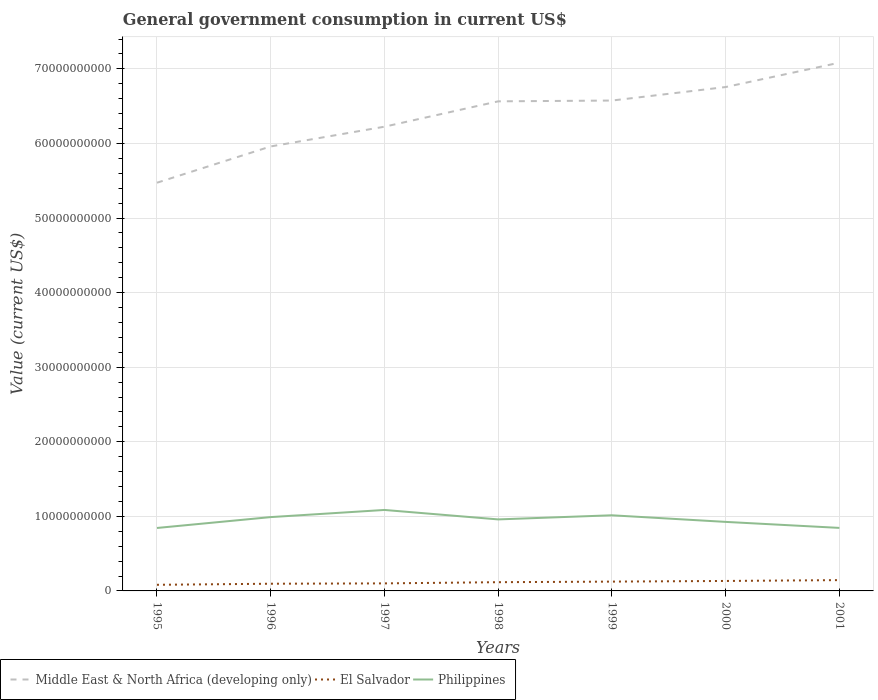Across all years, what is the maximum government conusmption in Middle East & North Africa (developing only)?
Provide a succinct answer. 5.47e+1. What is the total government conusmption in Philippines in the graph?
Provide a succinct answer. 2.41e+09. What is the difference between the highest and the second highest government conusmption in Middle East & North Africa (developing only)?
Ensure brevity in your answer.  1.61e+1. What is the difference between the highest and the lowest government conusmption in Middle East & North Africa (developing only)?
Keep it short and to the point. 4. Is the government conusmption in El Salvador strictly greater than the government conusmption in Philippines over the years?
Provide a short and direct response. Yes. How many lines are there?
Ensure brevity in your answer.  3. How many years are there in the graph?
Offer a very short reply. 7. Are the values on the major ticks of Y-axis written in scientific E-notation?
Offer a very short reply. No. Does the graph contain any zero values?
Provide a short and direct response. No. Does the graph contain grids?
Your answer should be very brief. Yes. Where does the legend appear in the graph?
Provide a short and direct response. Bottom left. How are the legend labels stacked?
Offer a very short reply. Horizontal. What is the title of the graph?
Your answer should be compact. General government consumption in current US$. What is the label or title of the Y-axis?
Keep it short and to the point. Value (current US$). What is the Value (current US$) of Middle East & North Africa (developing only) in 1995?
Ensure brevity in your answer.  5.47e+1. What is the Value (current US$) in El Salvador in 1995?
Your response must be concise. 8.21e+08. What is the Value (current US$) of Philippines in 1995?
Provide a short and direct response. 8.44e+09. What is the Value (current US$) in Middle East & North Africa (developing only) in 1996?
Offer a very short reply. 5.96e+1. What is the Value (current US$) of El Salvador in 1996?
Your answer should be very brief. 9.64e+08. What is the Value (current US$) in Philippines in 1996?
Offer a very short reply. 9.90e+09. What is the Value (current US$) in Middle East & North Africa (developing only) in 1997?
Provide a short and direct response. 6.22e+1. What is the Value (current US$) of El Salvador in 1997?
Provide a short and direct response. 1.01e+09. What is the Value (current US$) of Philippines in 1997?
Keep it short and to the point. 1.09e+1. What is the Value (current US$) of Middle East & North Africa (developing only) in 1998?
Ensure brevity in your answer.  6.56e+1. What is the Value (current US$) in El Salvador in 1998?
Make the answer very short. 1.17e+09. What is the Value (current US$) in Philippines in 1998?
Your response must be concise. 9.59e+09. What is the Value (current US$) of Middle East & North Africa (developing only) in 1999?
Give a very brief answer. 6.58e+1. What is the Value (current US$) of El Salvador in 1999?
Provide a succinct answer. 1.25e+09. What is the Value (current US$) in Philippines in 1999?
Provide a short and direct response. 1.01e+1. What is the Value (current US$) in Middle East & North Africa (developing only) in 2000?
Your response must be concise. 6.76e+1. What is the Value (current US$) in El Salvador in 2000?
Ensure brevity in your answer.  1.34e+09. What is the Value (current US$) in Philippines in 2000?
Ensure brevity in your answer.  9.26e+09. What is the Value (current US$) in Middle East & North Africa (developing only) in 2001?
Keep it short and to the point. 7.08e+1. What is the Value (current US$) of El Salvador in 2001?
Ensure brevity in your answer.  1.45e+09. What is the Value (current US$) in Philippines in 2001?
Ensure brevity in your answer.  8.45e+09. Across all years, what is the maximum Value (current US$) of Middle East & North Africa (developing only)?
Provide a short and direct response. 7.08e+1. Across all years, what is the maximum Value (current US$) in El Salvador?
Ensure brevity in your answer.  1.45e+09. Across all years, what is the maximum Value (current US$) of Philippines?
Provide a short and direct response. 1.09e+1. Across all years, what is the minimum Value (current US$) of Middle East & North Africa (developing only)?
Make the answer very short. 5.47e+1. Across all years, what is the minimum Value (current US$) of El Salvador?
Keep it short and to the point. 8.21e+08. Across all years, what is the minimum Value (current US$) of Philippines?
Make the answer very short. 8.44e+09. What is the total Value (current US$) of Middle East & North Africa (developing only) in the graph?
Your answer should be very brief. 4.46e+11. What is the total Value (current US$) of El Salvador in the graph?
Your response must be concise. 8.00e+09. What is the total Value (current US$) of Philippines in the graph?
Your response must be concise. 6.66e+1. What is the difference between the Value (current US$) in Middle East & North Africa (developing only) in 1995 and that in 1996?
Give a very brief answer. -4.87e+09. What is the difference between the Value (current US$) in El Salvador in 1995 and that in 1996?
Provide a succinct answer. -1.43e+08. What is the difference between the Value (current US$) of Philippines in 1995 and that in 1996?
Offer a terse response. -1.46e+09. What is the difference between the Value (current US$) in Middle East & North Africa (developing only) in 1995 and that in 1997?
Offer a very short reply. -7.51e+09. What is the difference between the Value (current US$) of El Salvador in 1995 and that in 1997?
Keep it short and to the point. -1.90e+08. What is the difference between the Value (current US$) of Philippines in 1995 and that in 1997?
Your answer should be compact. -2.42e+09. What is the difference between the Value (current US$) of Middle East & North Africa (developing only) in 1995 and that in 1998?
Provide a short and direct response. -1.09e+1. What is the difference between the Value (current US$) in El Salvador in 1995 and that in 1998?
Ensure brevity in your answer.  -3.50e+08. What is the difference between the Value (current US$) in Philippines in 1995 and that in 1998?
Provide a short and direct response. -1.15e+09. What is the difference between the Value (current US$) of Middle East & North Africa (developing only) in 1995 and that in 1999?
Ensure brevity in your answer.  -1.10e+1. What is the difference between the Value (current US$) in El Salvador in 1995 and that in 1999?
Provide a succinct answer. -4.28e+08. What is the difference between the Value (current US$) in Philippines in 1995 and that in 1999?
Offer a very short reply. -1.70e+09. What is the difference between the Value (current US$) in Middle East & North Africa (developing only) in 1995 and that in 2000?
Ensure brevity in your answer.  -1.28e+1. What is the difference between the Value (current US$) in El Salvador in 1995 and that in 2000?
Give a very brief answer. -5.15e+08. What is the difference between the Value (current US$) of Philippines in 1995 and that in 2000?
Provide a succinct answer. -8.16e+08. What is the difference between the Value (current US$) of Middle East & North Africa (developing only) in 1995 and that in 2001?
Ensure brevity in your answer.  -1.61e+1. What is the difference between the Value (current US$) in El Salvador in 1995 and that in 2001?
Give a very brief answer. -6.28e+08. What is the difference between the Value (current US$) in Philippines in 1995 and that in 2001?
Make the answer very short. -9.49e+06. What is the difference between the Value (current US$) of Middle East & North Africa (developing only) in 1996 and that in 1997?
Keep it short and to the point. -2.65e+09. What is the difference between the Value (current US$) in El Salvador in 1996 and that in 1997?
Keep it short and to the point. -4.62e+07. What is the difference between the Value (current US$) of Philippines in 1996 and that in 1997?
Your response must be concise. -9.57e+08. What is the difference between the Value (current US$) in Middle East & North Africa (developing only) in 1996 and that in 1998?
Give a very brief answer. -6.05e+09. What is the difference between the Value (current US$) of El Salvador in 1996 and that in 1998?
Give a very brief answer. -2.06e+08. What is the difference between the Value (current US$) in Philippines in 1996 and that in 1998?
Offer a very short reply. 3.10e+08. What is the difference between the Value (current US$) of Middle East & North Africa (developing only) in 1996 and that in 1999?
Make the answer very short. -6.15e+09. What is the difference between the Value (current US$) of El Salvador in 1996 and that in 1999?
Keep it short and to the point. -2.85e+08. What is the difference between the Value (current US$) of Philippines in 1996 and that in 1999?
Your answer should be very brief. -2.42e+08. What is the difference between the Value (current US$) of Middle East & North Africa (developing only) in 1996 and that in 2000?
Give a very brief answer. -7.96e+09. What is the difference between the Value (current US$) in El Salvador in 1996 and that in 2000?
Offer a terse response. -3.72e+08. What is the difference between the Value (current US$) in Philippines in 1996 and that in 2000?
Give a very brief answer. 6.43e+08. What is the difference between the Value (current US$) in Middle East & North Africa (developing only) in 1996 and that in 2001?
Your answer should be compact. -1.12e+1. What is the difference between the Value (current US$) in El Salvador in 1996 and that in 2001?
Your response must be concise. -4.84e+08. What is the difference between the Value (current US$) in Philippines in 1996 and that in 2001?
Give a very brief answer. 1.45e+09. What is the difference between the Value (current US$) in Middle East & North Africa (developing only) in 1997 and that in 1998?
Provide a succinct answer. -3.40e+09. What is the difference between the Value (current US$) of El Salvador in 1997 and that in 1998?
Offer a very short reply. -1.60e+08. What is the difference between the Value (current US$) of Philippines in 1997 and that in 1998?
Ensure brevity in your answer.  1.27e+09. What is the difference between the Value (current US$) of Middle East & North Africa (developing only) in 1997 and that in 1999?
Provide a succinct answer. -3.51e+09. What is the difference between the Value (current US$) of El Salvador in 1997 and that in 1999?
Your answer should be very brief. -2.38e+08. What is the difference between the Value (current US$) of Philippines in 1997 and that in 1999?
Keep it short and to the point. 7.15e+08. What is the difference between the Value (current US$) of Middle East & North Africa (developing only) in 1997 and that in 2000?
Provide a succinct answer. -5.32e+09. What is the difference between the Value (current US$) of El Salvador in 1997 and that in 2000?
Your answer should be compact. -3.26e+08. What is the difference between the Value (current US$) of Philippines in 1997 and that in 2000?
Offer a very short reply. 1.60e+09. What is the difference between the Value (current US$) of Middle East & North Africa (developing only) in 1997 and that in 2001?
Ensure brevity in your answer.  -8.58e+09. What is the difference between the Value (current US$) of El Salvador in 1997 and that in 2001?
Keep it short and to the point. -4.38e+08. What is the difference between the Value (current US$) in Philippines in 1997 and that in 2001?
Offer a terse response. 2.41e+09. What is the difference between the Value (current US$) of Middle East & North Africa (developing only) in 1998 and that in 1999?
Your response must be concise. -1.07e+08. What is the difference between the Value (current US$) in El Salvador in 1998 and that in 1999?
Offer a very short reply. -7.84e+07. What is the difference between the Value (current US$) of Philippines in 1998 and that in 1999?
Make the answer very short. -5.53e+08. What is the difference between the Value (current US$) in Middle East & North Africa (developing only) in 1998 and that in 2000?
Ensure brevity in your answer.  -1.92e+09. What is the difference between the Value (current US$) in El Salvador in 1998 and that in 2000?
Provide a short and direct response. -1.65e+08. What is the difference between the Value (current US$) in Philippines in 1998 and that in 2000?
Offer a terse response. 3.32e+08. What is the difference between the Value (current US$) in Middle East & North Africa (developing only) in 1998 and that in 2001?
Offer a terse response. -5.18e+09. What is the difference between the Value (current US$) of El Salvador in 1998 and that in 2001?
Your answer should be compact. -2.78e+08. What is the difference between the Value (current US$) of Philippines in 1998 and that in 2001?
Provide a short and direct response. 1.14e+09. What is the difference between the Value (current US$) in Middle East & North Africa (developing only) in 1999 and that in 2000?
Your answer should be compact. -1.81e+09. What is the difference between the Value (current US$) in El Salvador in 1999 and that in 2000?
Your response must be concise. -8.70e+07. What is the difference between the Value (current US$) of Philippines in 1999 and that in 2000?
Keep it short and to the point. 8.85e+08. What is the difference between the Value (current US$) in Middle East & North Africa (developing only) in 1999 and that in 2001?
Provide a succinct answer. -5.08e+09. What is the difference between the Value (current US$) in El Salvador in 1999 and that in 2001?
Offer a terse response. -2.00e+08. What is the difference between the Value (current US$) of Philippines in 1999 and that in 2001?
Offer a terse response. 1.69e+09. What is the difference between the Value (current US$) in Middle East & North Africa (developing only) in 2000 and that in 2001?
Your response must be concise. -3.27e+09. What is the difference between the Value (current US$) of El Salvador in 2000 and that in 2001?
Your answer should be very brief. -1.13e+08. What is the difference between the Value (current US$) of Philippines in 2000 and that in 2001?
Provide a succinct answer. 8.06e+08. What is the difference between the Value (current US$) of Middle East & North Africa (developing only) in 1995 and the Value (current US$) of El Salvador in 1996?
Keep it short and to the point. 5.38e+1. What is the difference between the Value (current US$) of Middle East & North Africa (developing only) in 1995 and the Value (current US$) of Philippines in 1996?
Your response must be concise. 4.48e+1. What is the difference between the Value (current US$) of El Salvador in 1995 and the Value (current US$) of Philippines in 1996?
Provide a succinct answer. -9.08e+09. What is the difference between the Value (current US$) in Middle East & North Africa (developing only) in 1995 and the Value (current US$) in El Salvador in 1997?
Offer a very short reply. 5.37e+1. What is the difference between the Value (current US$) in Middle East & North Africa (developing only) in 1995 and the Value (current US$) in Philippines in 1997?
Make the answer very short. 4.39e+1. What is the difference between the Value (current US$) of El Salvador in 1995 and the Value (current US$) of Philippines in 1997?
Offer a very short reply. -1.00e+1. What is the difference between the Value (current US$) of Middle East & North Africa (developing only) in 1995 and the Value (current US$) of El Salvador in 1998?
Ensure brevity in your answer.  5.36e+1. What is the difference between the Value (current US$) in Middle East & North Africa (developing only) in 1995 and the Value (current US$) in Philippines in 1998?
Provide a short and direct response. 4.51e+1. What is the difference between the Value (current US$) of El Salvador in 1995 and the Value (current US$) of Philippines in 1998?
Ensure brevity in your answer.  -8.77e+09. What is the difference between the Value (current US$) in Middle East & North Africa (developing only) in 1995 and the Value (current US$) in El Salvador in 1999?
Give a very brief answer. 5.35e+1. What is the difference between the Value (current US$) of Middle East & North Africa (developing only) in 1995 and the Value (current US$) of Philippines in 1999?
Make the answer very short. 4.46e+1. What is the difference between the Value (current US$) of El Salvador in 1995 and the Value (current US$) of Philippines in 1999?
Keep it short and to the point. -9.32e+09. What is the difference between the Value (current US$) in Middle East & North Africa (developing only) in 1995 and the Value (current US$) in El Salvador in 2000?
Ensure brevity in your answer.  5.34e+1. What is the difference between the Value (current US$) of Middle East & North Africa (developing only) in 1995 and the Value (current US$) of Philippines in 2000?
Provide a short and direct response. 4.55e+1. What is the difference between the Value (current US$) in El Salvador in 1995 and the Value (current US$) in Philippines in 2000?
Ensure brevity in your answer.  -8.44e+09. What is the difference between the Value (current US$) of Middle East & North Africa (developing only) in 1995 and the Value (current US$) of El Salvador in 2001?
Ensure brevity in your answer.  5.33e+1. What is the difference between the Value (current US$) of Middle East & North Africa (developing only) in 1995 and the Value (current US$) of Philippines in 2001?
Keep it short and to the point. 4.63e+1. What is the difference between the Value (current US$) of El Salvador in 1995 and the Value (current US$) of Philippines in 2001?
Keep it short and to the point. -7.63e+09. What is the difference between the Value (current US$) in Middle East & North Africa (developing only) in 1996 and the Value (current US$) in El Salvador in 1997?
Your answer should be very brief. 5.86e+1. What is the difference between the Value (current US$) of Middle East & North Africa (developing only) in 1996 and the Value (current US$) of Philippines in 1997?
Keep it short and to the point. 4.87e+1. What is the difference between the Value (current US$) in El Salvador in 1996 and the Value (current US$) in Philippines in 1997?
Provide a succinct answer. -9.89e+09. What is the difference between the Value (current US$) in Middle East & North Africa (developing only) in 1996 and the Value (current US$) in El Salvador in 1998?
Your answer should be compact. 5.84e+1. What is the difference between the Value (current US$) of Middle East & North Africa (developing only) in 1996 and the Value (current US$) of Philippines in 1998?
Ensure brevity in your answer.  5.00e+1. What is the difference between the Value (current US$) of El Salvador in 1996 and the Value (current US$) of Philippines in 1998?
Give a very brief answer. -8.62e+09. What is the difference between the Value (current US$) in Middle East & North Africa (developing only) in 1996 and the Value (current US$) in El Salvador in 1999?
Your response must be concise. 5.83e+1. What is the difference between the Value (current US$) of Middle East & North Africa (developing only) in 1996 and the Value (current US$) of Philippines in 1999?
Make the answer very short. 4.95e+1. What is the difference between the Value (current US$) of El Salvador in 1996 and the Value (current US$) of Philippines in 1999?
Provide a succinct answer. -9.18e+09. What is the difference between the Value (current US$) of Middle East & North Africa (developing only) in 1996 and the Value (current US$) of El Salvador in 2000?
Provide a succinct answer. 5.83e+1. What is the difference between the Value (current US$) in Middle East & North Africa (developing only) in 1996 and the Value (current US$) in Philippines in 2000?
Your answer should be very brief. 5.03e+1. What is the difference between the Value (current US$) in El Salvador in 1996 and the Value (current US$) in Philippines in 2000?
Ensure brevity in your answer.  -8.29e+09. What is the difference between the Value (current US$) of Middle East & North Africa (developing only) in 1996 and the Value (current US$) of El Salvador in 2001?
Provide a succinct answer. 5.81e+1. What is the difference between the Value (current US$) of Middle East & North Africa (developing only) in 1996 and the Value (current US$) of Philippines in 2001?
Provide a succinct answer. 5.11e+1. What is the difference between the Value (current US$) in El Salvador in 1996 and the Value (current US$) in Philippines in 2001?
Your answer should be very brief. -7.49e+09. What is the difference between the Value (current US$) in Middle East & North Africa (developing only) in 1997 and the Value (current US$) in El Salvador in 1998?
Your answer should be very brief. 6.11e+1. What is the difference between the Value (current US$) in Middle East & North Africa (developing only) in 1997 and the Value (current US$) in Philippines in 1998?
Provide a short and direct response. 5.27e+1. What is the difference between the Value (current US$) of El Salvador in 1997 and the Value (current US$) of Philippines in 1998?
Give a very brief answer. -8.58e+09. What is the difference between the Value (current US$) of Middle East & North Africa (developing only) in 1997 and the Value (current US$) of El Salvador in 1999?
Give a very brief answer. 6.10e+1. What is the difference between the Value (current US$) in Middle East & North Africa (developing only) in 1997 and the Value (current US$) in Philippines in 1999?
Provide a short and direct response. 5.21e+1. What is the difference between the Value (current US$) in El Salvador in 1997 and the Value (current US$) in Philippines in 1999?
Your answer should be compact. -9.13e+09. What is the difference between the Value (current US$) in Middle East & North Africa (developing only) in 1997 and the Value (current US$) in El Salvador in 2000?
Provide a short and direct response. 6.09e+1. What is the difference between the Value (current US$) of Middle East & North Africa (developing only) in 1997 and the Value (current US$) of Philippines in 2000?
Provide a succinct answer. 5.30e+1. What is the difference between the Value (current US$) in El Salvador in 1997 and the Value (current US$) in Philippines in 2000?
Keep it short and to the point. -8.25e+09. What is the difference between the Value (current US$) of Middle East & North Africa (developing only) in 1997 and the Value (current US$) of El Salvador in 2001?
Provide a short and direct response. 6.08e+1. What is the difference between the Value (current US$) of Middle East & North Africa (developing only) in 1997 and the Value (current US$) of Philippines in 2001?
Your response must be concise. 5.38e+1. What is the difference between the Value (current US$) in El Salvador in 1997 and the Value (current US$) in Philippines in 2001?
Your answer should be compact. -7.44e+09. What is the difference between the Value (current US$) of Middle East & North Africa (developing only) in 1998 and the Value (current US$) of El Salvador in 1999?
Ensure brevity in your answer.  6.44e+1. What is the difference between the Value (current US$) of Middle East & North Africa (developing only) in 1998 and the Value (current US$) of Philippines in 1999?
Give a very brief answer. 5.55e+1. What is the difference between the Value (current US$) in El Salvador in 1998 and the Value (current US$) in Philippines in 1999?
Your answer should be compact. -8.97e+09. What is the difference between the Value (current US$) of Middle East & North Africa (developing only) in 1998 and the Value (current US$) of El Salvador in 2000?
Provide a short and direct response. 6.43e+1. What is the difference between the Value (current US$) of Middle East & North Africa (developing only) in 1998 and the Value (current US$) of Philippines in 2000?
Make the answer very short. 5.64e+1. What is the difference between the Value (current US$) in El Salvador in 1998 and the Value (current US$) in Philippines in 2000?
Keep it short and to the point. -8.09e+09. What is the difference between the Value (current US$) of Middle East & North Africa (developing only) in 1998 and the Value (current US$) of El Salvador in 2001?
Your answer should be very brief. 6.42e+1. What is the difference between the Value (current US$) of Middle East & North Africa (developing only) in 1998 and the Value (current US$) of Philippines in 2001?
Ensure brevity in your answer.  5.72e+1. What is the difference between the Value (current US$) in El Salvador in 1998 and the Value (current US$) in Philippines in 2001?
Offer a terse response. -7.28e+09. What is the difference between the Value (current US$) in Middle East & North Africa (developing only) in 1999 and the Value (current US$) in El Salvador in 2000?
Offer a very short reply. 6.44e+1. What is the difference between the Value (current US$) of Middle East & North Africa (developing only) in 1999 and the Value (current US$) of Philippines in 2000?
Offer a very short reply. 5.65e+1. What is the difference between the Value (current US$) of El Salvador in 1999 and the Value (current US$) of Philippines in 2000?
Offer a very short reply. -8.01e+09. What is the difference between the Value (current US$) of Middle East & North Africa (developing only) in 1999 and the Value (current US$) of El Salvador in 2001?
Provide a succinct answer. 6.43e+1. What is the difference between the Value (current US$) of Middle East & North Africa (developing only) in 1999 and the Value (current US$) of Philippines in 2001?
Provide a short and direct response. 5.73e+1. What is the difference between the Value (current US$) of El Salvador in 1999 and the Value (current US$) of Philippines in 2001?
Provide a succinct answer. -7.20e+09. What is the difference between the Value (current US$) in Middle East & North Africa (developing only) in 2000 and the Value (current US$) in El Salvador in 2001?
Keep it short and to the point. 6.61e+1. What is the difference between the Value (current US$) in Middle East & North Africa (developing only) in 2000 and the Value (current US$) in Philippines in 2001?
Ensure brevity in your answer.  5.91e+1. What is the difference between the Value (current US$) of El Salvador in 2000 and the Value (current US$) of Philippines in 2001?
Your response must be concise. -7.11e+09. What is the average Value (current US$) in Middle East & North Africa (developing only) per year?
Your answer should be compact. 6.38e+1. What is the average Value (current US$) in El Salvador per year?
Ensure brevity in your answer.  1.14e+09. What is the average Value (current US$) in Philippines per year?
Make the answer very short. 9.52e+09. In the year 1995, what is the difference between the Value (current US$) of Middle East & North Africa (developing only) and Value (current US$) of El Salvador?
Ensure brevity in your answer.  5.39e+1. In the year 1995, what is the difference between the Value (current US$) of Middle East & North Africa (developing only) and Value (current US$) of Philippines?
Your response must be concise. 4.63e+1. In the year 1995, what is the difference between the Value (current US$) in El Salvador and Value (current US$) in Philippines?
Keep it short and to the point. -7.62e+09. In the year 1996, what is the difference between the Value (current US$) in Middle East & North Africa (developing only) and Value (current US$) in El Salvador?
Provide a short and direct response. 5.86e+1. In the year 1996, what is the difference between the Value (current US$) in Middle East & North Africa (developing only) and Value (current US$) in Philippines?
Offer a terse response. 4.97e+1. In the year 1996, what is the difference between the Value (current US$) of El Salvador and Value (current US$) of Philippines?
Ensure brevity in your answer.  -8.93e+09. In the year 1997, what is the difference between the Value (current US$) of Middle East & North Africa (developing only) and Value (current US$) of El Salvador?
Make the answer very short. 6.12e+1. In the year 1997, what is the difference between the Value (current US$) in Middle East & North Africa (developing only) and Value (current US$) in Philippines?
Your answer should be very brief. 5.14e+1. In the year 1997, what is the difference between the Value (current US$) of El Salvador and Value (current US$) of Philippines?
Your answer should be very brief. -9.85e+09. In the year 1998, what is the difference between the Value (current US$) of Middle East & North Africa (developing only) and Value (current US$) of El Salvador?
Keep it short and to the point. 6.45e+1. In the year 1998, what is the difference between the Value (current US$) of Middle East & North Africa (developing only) and Value (current US$) of Philippines?
Give a very brief answer. 5.61e+1. In the year 1998, what is the difference between the Value (current US$) in El Salvador and Value (current US$) in Philippines?
Your response must be concise. -8.42e+09. In the year 1999, what is the difference between the Value (current US$) of Middle East & North Africa (developing only) and Value (current US$) of El Salvador?
Give a very brief answer. 6.45e+1. In the year 1999, what is the difference between the Value (current US$) of Middle East & North Africa (developing only) and Value (current US$) of Philippines?
Provide a short and direct response. 5.56e+1. In the year 1999, what is the difference between the Value (current US$) in El Salvador and Value (current US$) in Philippines?
Give a very brief answer. -8.89e+09. In the year 2000, what is the difference between the Value (current US$) in Middle East & North Africa (developing only) and Value (current US$) in El Salvador?
Keep it short and to the point. 6.62e+1. In the year 2000, what is the difference between the Value (current US$) of Middle East & North Africa (developing only) and Value (current US$) of Philippines?
Provide a short and direct response. 5.83e+1. In the year 2000, what is the difference between the Value (current US$) of El Salvador and Value (current US$) of Philippines?
Give a very brief answer. -7.92e+09. In the year 2001, what is the difference between the Value (current US$) in Middle East & North Africa (developing only) and Value (current US$) in El Salvador?
Your answer should be compact. 6.94e+1. In the year 2001, what is the difference between the Value (current US$) in Middle East & North Africa (developing only) and Value (current US$) in Philippines?
Offer a terse response. 6.24e+1. In the year 2001, what is the difference between the Value (current US$) in El Salvador and Value (current US$) in Philippines?
Your answer should be compact. -7.00e+09. What is the ratio of the Value (current US$) of Middle East & North Africa (developing only) in 1995 to that in 1996?
Make the answer very short. 0.92. What is the ratio of the Value (current US$) of El Salvador in 1995 to that in 1996?
Make the answer very short. 0.85. What is the ratio of the Value (current US$) of Philippines in 1995 to that in 1996?
Provide a short and direct response. 0.85. What is the ratio of the Value (current US$) in Middle East & North Africa (developing only) in 1995 to that in 1997?
Offer a very short reply. 0.88. What is the ratio of the Value (current US$) in El Salvador in 1995 to that in 1997?
Provide a short and direct response. 0.81. What is the ratio of the Value (current US$) in Philippines in 1995 to that in 1997?
Give a very brief answer. 0.78. What is the ratio of the Value (current US$) in Middle East & North Africa (developing only) in 1995 to that in 1998?
Your answer should be very brief. 0.83. What is the ratio of the Value (current US$) in El Salvador in 1995 to that in 1998?
Provide a short and direct response. 0.7. What is the ratio of the Value (current US$) of Philippines in 1995 to that in 1998?
Your answer should be compact. 0.88. What is the ratio of the Value (current US$) of Middle East & North Africa (developing only) in 1995 to that in 1999?
Your answer should be compact. 0.83. What is the ratio of the Value (current US$) in El Salvador in 1995 to that in 1999?
Make the answer very short. 0.66. What is the ratio of the Value (current US$) of Philippines in 1995 to that in 1999?
Provide a succinct answer. 0.83. What is the ratio of the Value (current US$) of Middle East & North Africa (developing only) in 1995 to that in 2000?
Provide a succinct answer. 0.81. What is the ratio of the Value (current US$) of El Salvador in 1995 to that in 2000?
Ensure brevity in your answer.  0.61. What is the ratio of the Value (current US$) of Philippines in 1995 to that in 2000?
Offer a terse response. 0.91. What is the ratio of the Value (current US$) in Middle East & North Africa (developing only) in 1995 to that in 2001?
Your answer should be compact. 0.77. What is the ratio of the Value (current US$) in El Salvador in 1995 to that in 2001?
Ensure brevity in your answer.  0.57. What is the ratio of the Value (current US$) of Middle East & North Africa (developing only) in 1996 to that in 1997?
Offer a very short reply. 0.96. What is the ratio of the Value (current US$) of El Salvador in 1996 to that in 1997?
Your answer should be very brief. 0.95. What is the ratio of the Value (current US$) of Philippines in 1996 to that in 1997?
Offer a very short reply. 0.91. What is the ratio of the Value (current US$) in Middle East & North Africa (developing only) in 1996 to that in 1998?
Ensure brevity in your answer.  0.91. What is the ratio of the Value (current US$) of El Salvador in 1996 to that in 1998?
Ensure brevity in your answer.  0.82. What is the ratio of the Value (current US$) in Philippines in 1996 to that in 1998?
Make the answer very short. 1.03. What is the ratio of the Value (current US$) of Middle East & North Africa (developing only) in 1996 to that in 1999?
Offer a terse response. 0.91. What is the ratio of the Value (current US$) in El Salvador in 1996 to that in 1999?
Provide a succinct answer. 0.77. What is the ratio of the Value (current US$) in Philippines in 1996 to that in 1999?
Ensure brevity in your answer.  0.98. What is the ratio of the Value (current US$) in Middle East & North Africa (developing only) in 1996 to that in 2000?
Your answer should be very brief. 0.88. What is the ratio of the Value (current US$) in El Salvador in 1996 to that in 2000?
Your response must be concise. 0.72. What is the ratio of the Value (current US$) of Philippines in 1996 to that in 2000?
Provide a short and direct response. 1.07. What is the ratio of the Value (current US$) of Middle East & North Africa (developing only) in 1996 to that in 2001?
Give a very brief answer. 0.84. What is the ratio of the Value (current US$) of El Salvador in 1996 to that in 2001?
Provide a succinct answer. 0.67. What is the ratio of the Value (current US$) in Philippines in 1996 to that in 2001?
Provide a short and direct response. 1.17. What is the ratio of the Value (current US$) of Middle East & North Africa (developing only) in 1997 to that in 1998?
Give a very brief answer. 0.95. What is the ratio of the Value (current US$) in El Salvador in 1997 to that in 1998?
Make the answer very short. 0.86. What is the ratio of the Value (current US$) in Philippines in 1997 to that in 1998?
Keep it short and to the point. 1.13. What is the ratio of the Value (current US$) in Middle East & North Africa (developing only) in 1997 to that in 1999?
Provide a succinct answer. 0.95. What is the ratio of the Value (current US$) of El Salvador in 1997 to that in 1999?
Provide a succinct answer. 0.81. What is the ratio of the Value (current US$) of Philippines in 1997 to that in 1999?
Ensure brevity in your answer.  1.07. What is the ratio of the Value (current US$) of Middle East & North Africa (developing only) in 1997 to that in 2000?
Offer a very short reply. 0.92. What is the ratio of the Value (current US$) of El Salvador in 1997 to that in 2000?
Make the answer very short. 0.76. What is the ratio of the Value (current US$) in Philippines in 1997 to that in 2000?
Give a very brief answer. 1.17. What is the ratio of the Value (current US$) in Middle East & North Africa (developing only) in 1997 to that in 2001?
Your response must be concise. 0.88. What is the ratio of the Value (current US$) in El Salvador in 1997 to that in 2001?
Offer a terse response. 0.7. What is the ratio of the Value (current US$) of Philippines in 1997 to that in 2001?
Your answer should be very brief. 1.28. What is the ratio of the Value (current US$) of El Salvador in 1998 to that in 1999?
Offer a terse response. 0.94. What is the ratio of the Value (current US$) in Philippines in 1998 to that in 1999?
Keep it short and to the point. 0.95. What is the ratio of the Value (current US$) of Middle East & North Africa (developing only) in 1998 to that in 2000?
Keep it short and to the point. 0.97. What is the ratio of the Value (current US$) in El Salvador in 1998 to that in 2000?
Provide a short and direct response. 0.88. What is the ratio of the Value (current US$) of Philippines in 1998 to that in 2000?
Provide a succinct answer. 1.04. What is the ratio of the Value (current US$) in Middle East & North Africa (developing only) in 1998 to that in 2001?
Your answer should be compact. 0.93. What is the ratio of the Value (current US$) of El Salvador in 1998 to that in 2001?
Your answer should be compact. 0.81. What is the ratio of the Value (current US$) of Philippines in 1998 to that in 2001?
Make the answer very short. 1.13. What is the ratio of the Value (current US$) of Middle East & North Africa (developing only) in 1999 to that in 2000?
Make the answer very short. 0.97. What is the ratio of the Value (current US$) of El Salvador in 1999 to that in 2000?
Make the answer very short. 0.93. What is the ratio of the Value (current US$) in Philippines in 1999 to that in 2000?
Make the answer very short. 1.1. What is the ratio of the Value (current US$) of Middle East & North Africa (developing only) in 1999 to that in 2001?
Make the answer very short. 0.93. What is the ratio of the Value (current US$) of El Salvador in 1999 to that in 2001?
Offer a terse response. 0.86. What is the ratio of the Value (current US$) of Philippines in 1999 to that in 2001?
Your answer should be very brief. 1.2. What is the ratio of the Value (current US$) in Middle East & North Africa (developing only) in 2000 to that in 2001?
Give a very brief answer. 0.95. What is the ratio of the Value (current US$) of El Salvador in 2000 to that in 2001?
Your answer should be very brief. 0.92. What is the ratio of the Value (current US$) in Philippines in 2000 to that in 2001?
Keep it short and to the point. 1.1. What is the difference between the highest and the second highest Value (current US$) in Middle East & North Africa (developing only)?
Make the answer very short. 3.27e+09. What is the difference between the highest and the second highest Value (current US$) in El Salvador?
Offer a terse response. 1.13e+08. What is the difference between the highest and the second highest Value (current US$) in Philippines?
Your answer should be compact. 7.15e+08. What is the difference between the highest and the lowest Value (current US$) in Middle East & North Africa (developing only)?
Offer a very short reply. 1.61e+1. What is the difference between the highest and the lowest Value (current US$) of El Salvador?
Make the answer very short. 6.28e+08. What is the difference between the highest and the lowest Value (current US$) in Philippines?
Your answer should be compact. 2.42e+09. 